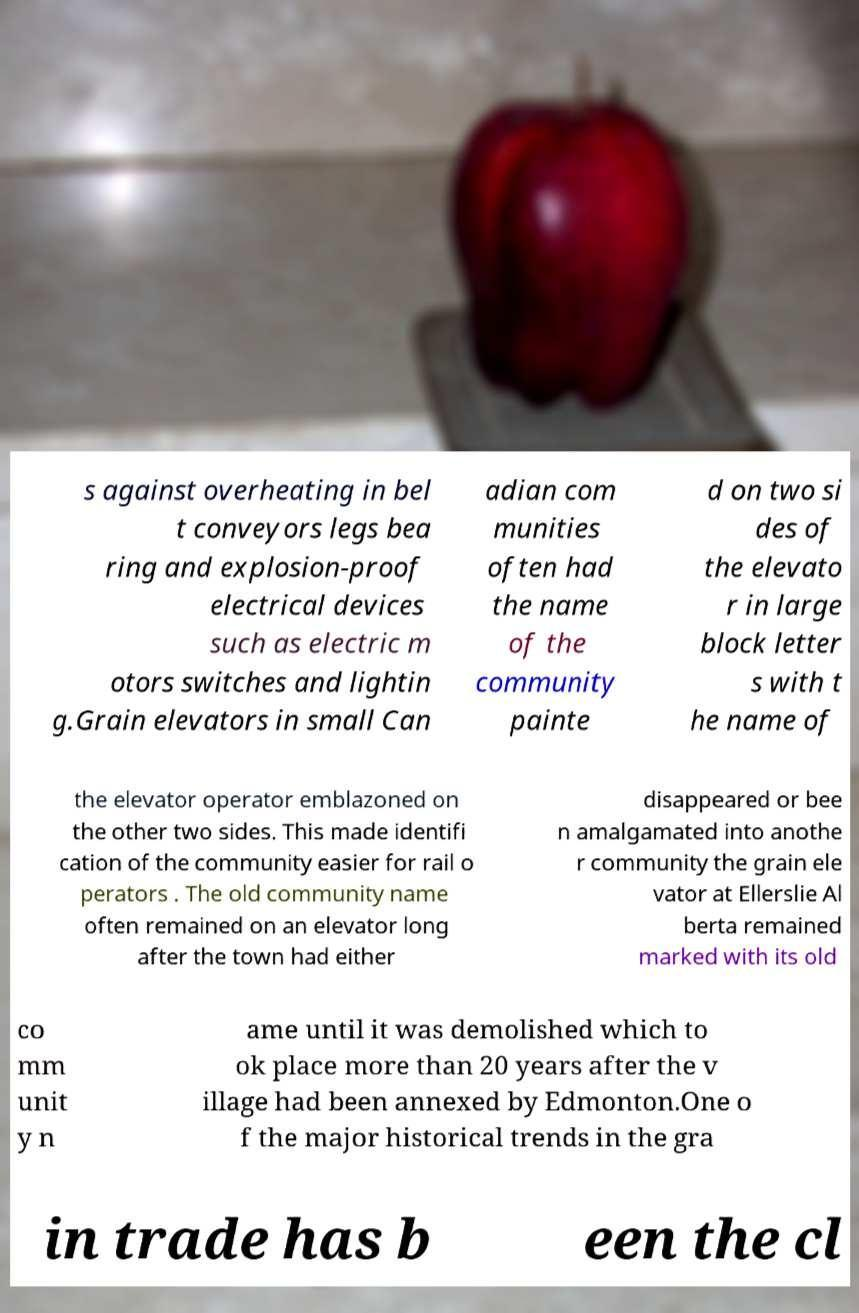Please identify and transcribe the text found in this image. s against overheating in bel t conveyors legs bea ring and explosion-proof electrical devices such as electric m otors switches and lightin g.Grain elevators in small Can adian com munities often had the name of the community painte d on two si des of the elevato r in large block letter s with t he name of the elevator operator emblazoned on the other two sides. This made identifi cation of the community easier for rail o perators . The old community name often remained on an elevator long after the town had either disappeared or bee n amalgamated into anothe r community the grain ele vator at Ellerslie Al berta remained marked with its old co mm unit y n ame until it was demolished which to ok place more than 20 years after the v illage had been annexed by Edmonton.One o f the major historical trends in the gra in trade has b een the cl 